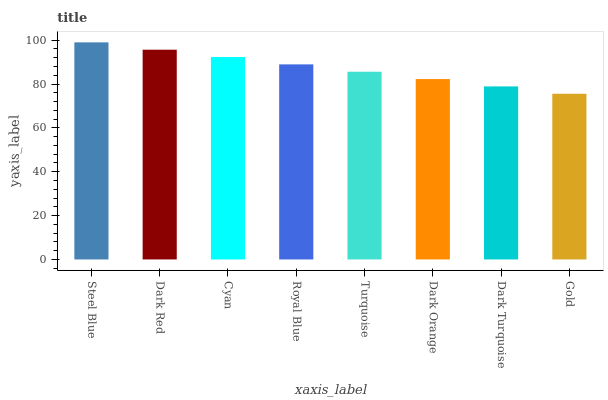Is Gold the minimum?
Answer yes or no. Yes. Is Steel Blue the maximum?
Answer yes or no. Yes. Is Dark Red the minimum?
Answer yes or no. No. Is Dark Red the maximum?
Answer yes or no. No. Is Steel Blue greater than Dark Red?
Answer yes or no. Yes. Is Dark Red less than Steel Blue?
Answer yes or no. Yes. Is Dark Red greater than Steel Blue?
Answer yes or no. No. Is Steel Blue less than Dark Red?
Answer yes or no. No. Is Royal Blue the high median?
Answer yes or no. Yes. Is Turquoise the low median?
Answer yes or no. Yes. Is Steel Blue the high median?
Answer yes or no. No. Is Dark Turquoise the low median?
Answer yes or no. No. 